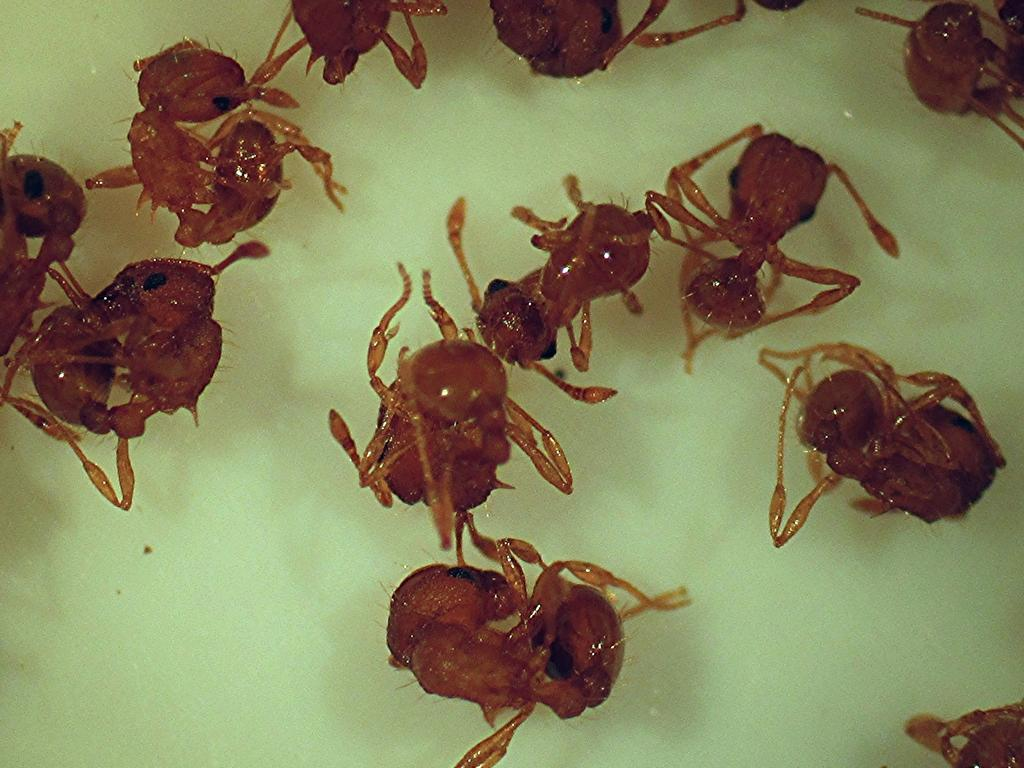What type of creatures are present in the image? There are ants in the image. What color are the ants? The ants are in red color. Where are the ants located in the image? The ants are in water. What type of drain can be seen in the image? There is no drain present in the image; it features red ants in water. Are the ants wearing underwear in the image? Ants do not wear underwear, and there are no human-like features in the image. 